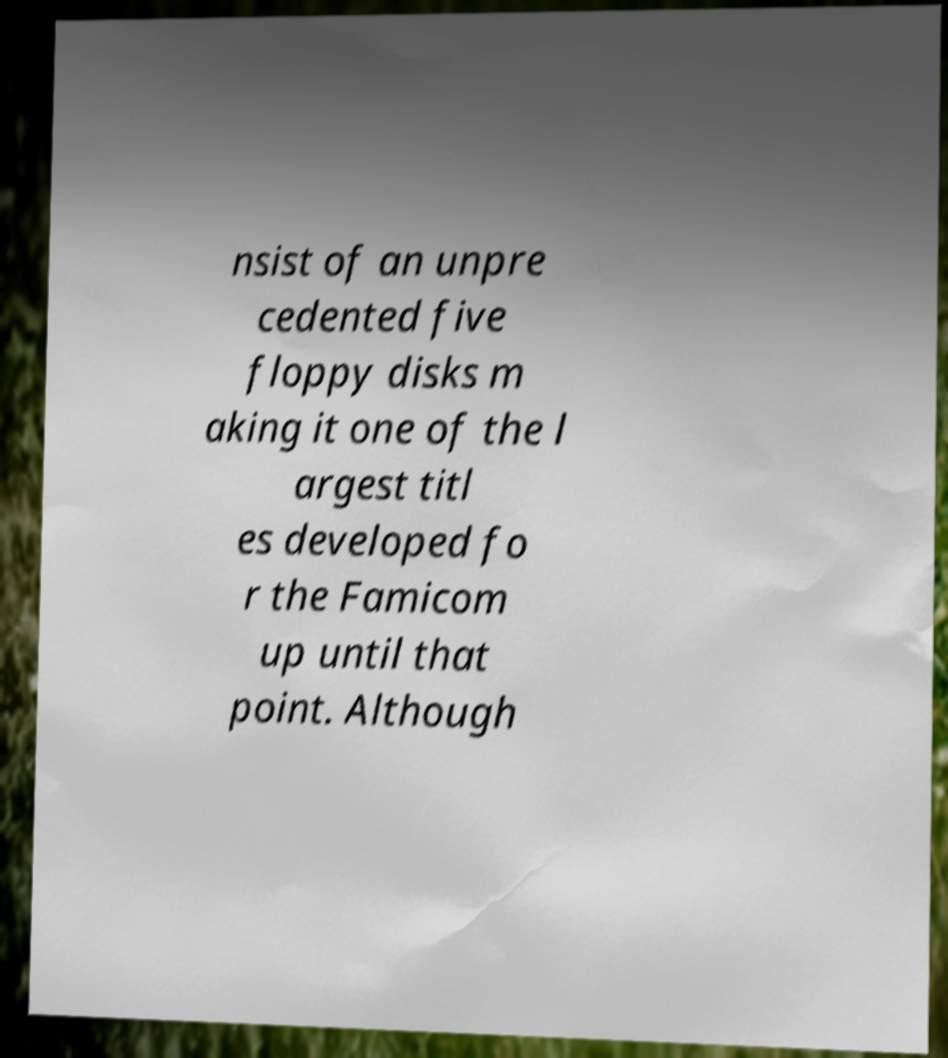Could you extract and type out the text from this image? nsist of an unpre cedented five floppy disks m aking it one of the l argest titl es developed fo r the Famicom up until that point. Although 